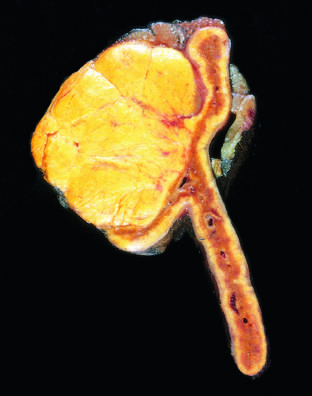s the late-phase reaction distinguished from nodular hyperplasia by its solitary, circumscribed nature?
Answer the question using a single word or phrase. No 